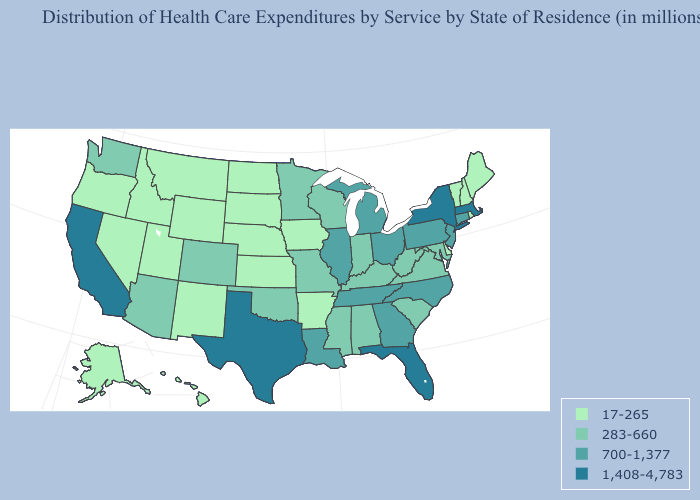Is the legend a continuous bar?
Give a very brief answer. No. Does Nebraska have the same value as Maine?
Quick response, please. Yes. What is the highest value in states that border North Carolina?
Keep it brief. 700-1,377. Does Nebraska have a lower value than New Mexico?
Write a very short answer. No. Name the states that have a value in the range 283-660?
Be succinct. Alabama, Arizona, Colorado, Indiana, Kentucky, Maryland, Minnesota, Mississippi, Missouri, Oklahoma, South Carolina, Virginia, Washington, West Virginia, Wisconsin. Name the states that have a value in the range 1,408-4,783?
Be succinct. California, Florida, Massachusetts, New York, Texas. Name the states that have a value in the range 1,408-4,783?
Keep it brief. California, Florida, Massachusetts, New York, Texas. Does Nebraska have the same value as Illinois?
Write a very short answer. No. What is the value of West Virginia?
Keep it brief. 283-660. What is the lowest value in the USA?
Give a very brief answer. 17-265. Name the states that have a value in the range 17-265?
Keep it brief. Alaska, Arkansas, Delaware, Hawaii, Idaho, Iowa, Kansas, Maine, Montana, Nebraska, Nevada, New Hampshire, New Mexico, North Dakota, Oregon, Rhode Island, South Dakota, Utah, Vermont, Wyoming. What is the value of Iowa?
Concise answer only. 17-265. Does Arizona have the same value as Wisconsin?
Keep it brief. Yes. What is the value of Illinois?
Write a very short answer. 700-1,377. What is the value of Washington?
Answer briefly. 283-660. 